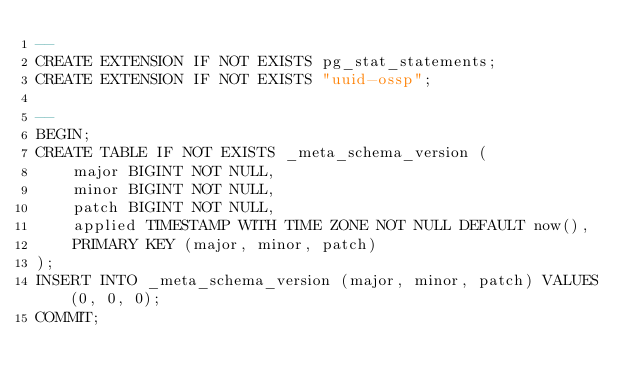Convert code to text. <code><loc_0><loc_0><loc_500><loc_500><_SQL_>--
CREATE EXTENSION IF NOT EXISTS pg_stat_statements;
CREATE EXTENSION IF NOT EXISTS "uuid-ossp";

--
BEGIN;
CREATE TABLE IF NOT EXISTS _meta_schema_version (
	major BIGINT NOT NULL,
	minor BIGINT NOT NULL,
	patch BIGINT NOT NULL,
	applied TIMESTAMP WITH TIME ZONE NOT NULL DEFAULT now(),
	PRIMARY KEY (major, minor, patch)
);
INSERT INTO _meta_schema_version (major, minor, patch) VALUES (0, 0, 0);
COMMIT;
</code> 